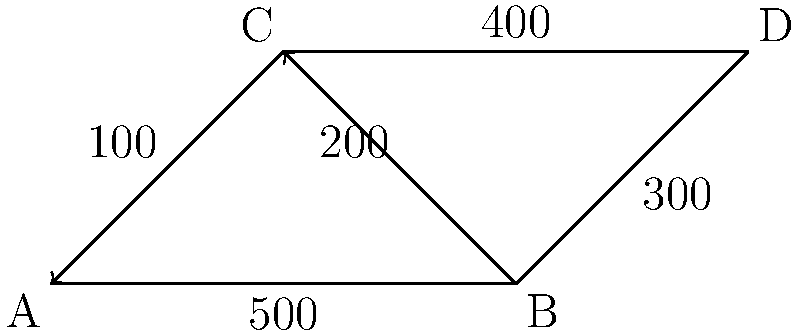As a crime reporter, you're investigating a series of thefts in a small city. The police suspect the criminals are using specific routes to escape quickly. Given the traffic flow diagram of the city's main intersections (A, B, C, and D) with hourly vehicle counts on each road, which intersection would you recommend the police to monitor closely to have the highest chance of intercepting the suspects? To determine the best intersection for police monitoring, we need to calculate the total traffic flow through each intersection:

1. Intersection A:
   Incoming: 100 (from C)
   Outgoing: 500 (to B)
   Total flow: 100 + 500 = 600 vehicles/hour

2. Intersection B:
   Incoming: 500 (from A)
   Outgoing: 300 (to D) + 200 (to C)
   Total flow: 500 + 300 + 200 = 1000 vehicles/hour

3. Intersection C:
   Incoming: 200 (from B) + 100 (from A)
   Outgoing: 400 (to D)
   Total flow: 200 + 100 + 400 = 700 vehicles/hour

4. Intersection D:
   Incoming: 300 (from B) + 400 (from C)
   Outgoing: 0 (assuming it's an exit point)
   Total flow: 300 + 400 = 700 vehicles/hour

The intersection with the highest total traffic flow is B, with 1000 vehicles/hour. This makes it the busiest intersection and the most likely point for criminals to pass through when escaping.

Additionally, intersection B is connected to all other intersections, either directly or indirectly, making it a strategic point for monitoring multiple routes simultaneously.
Answer: Intersection B 